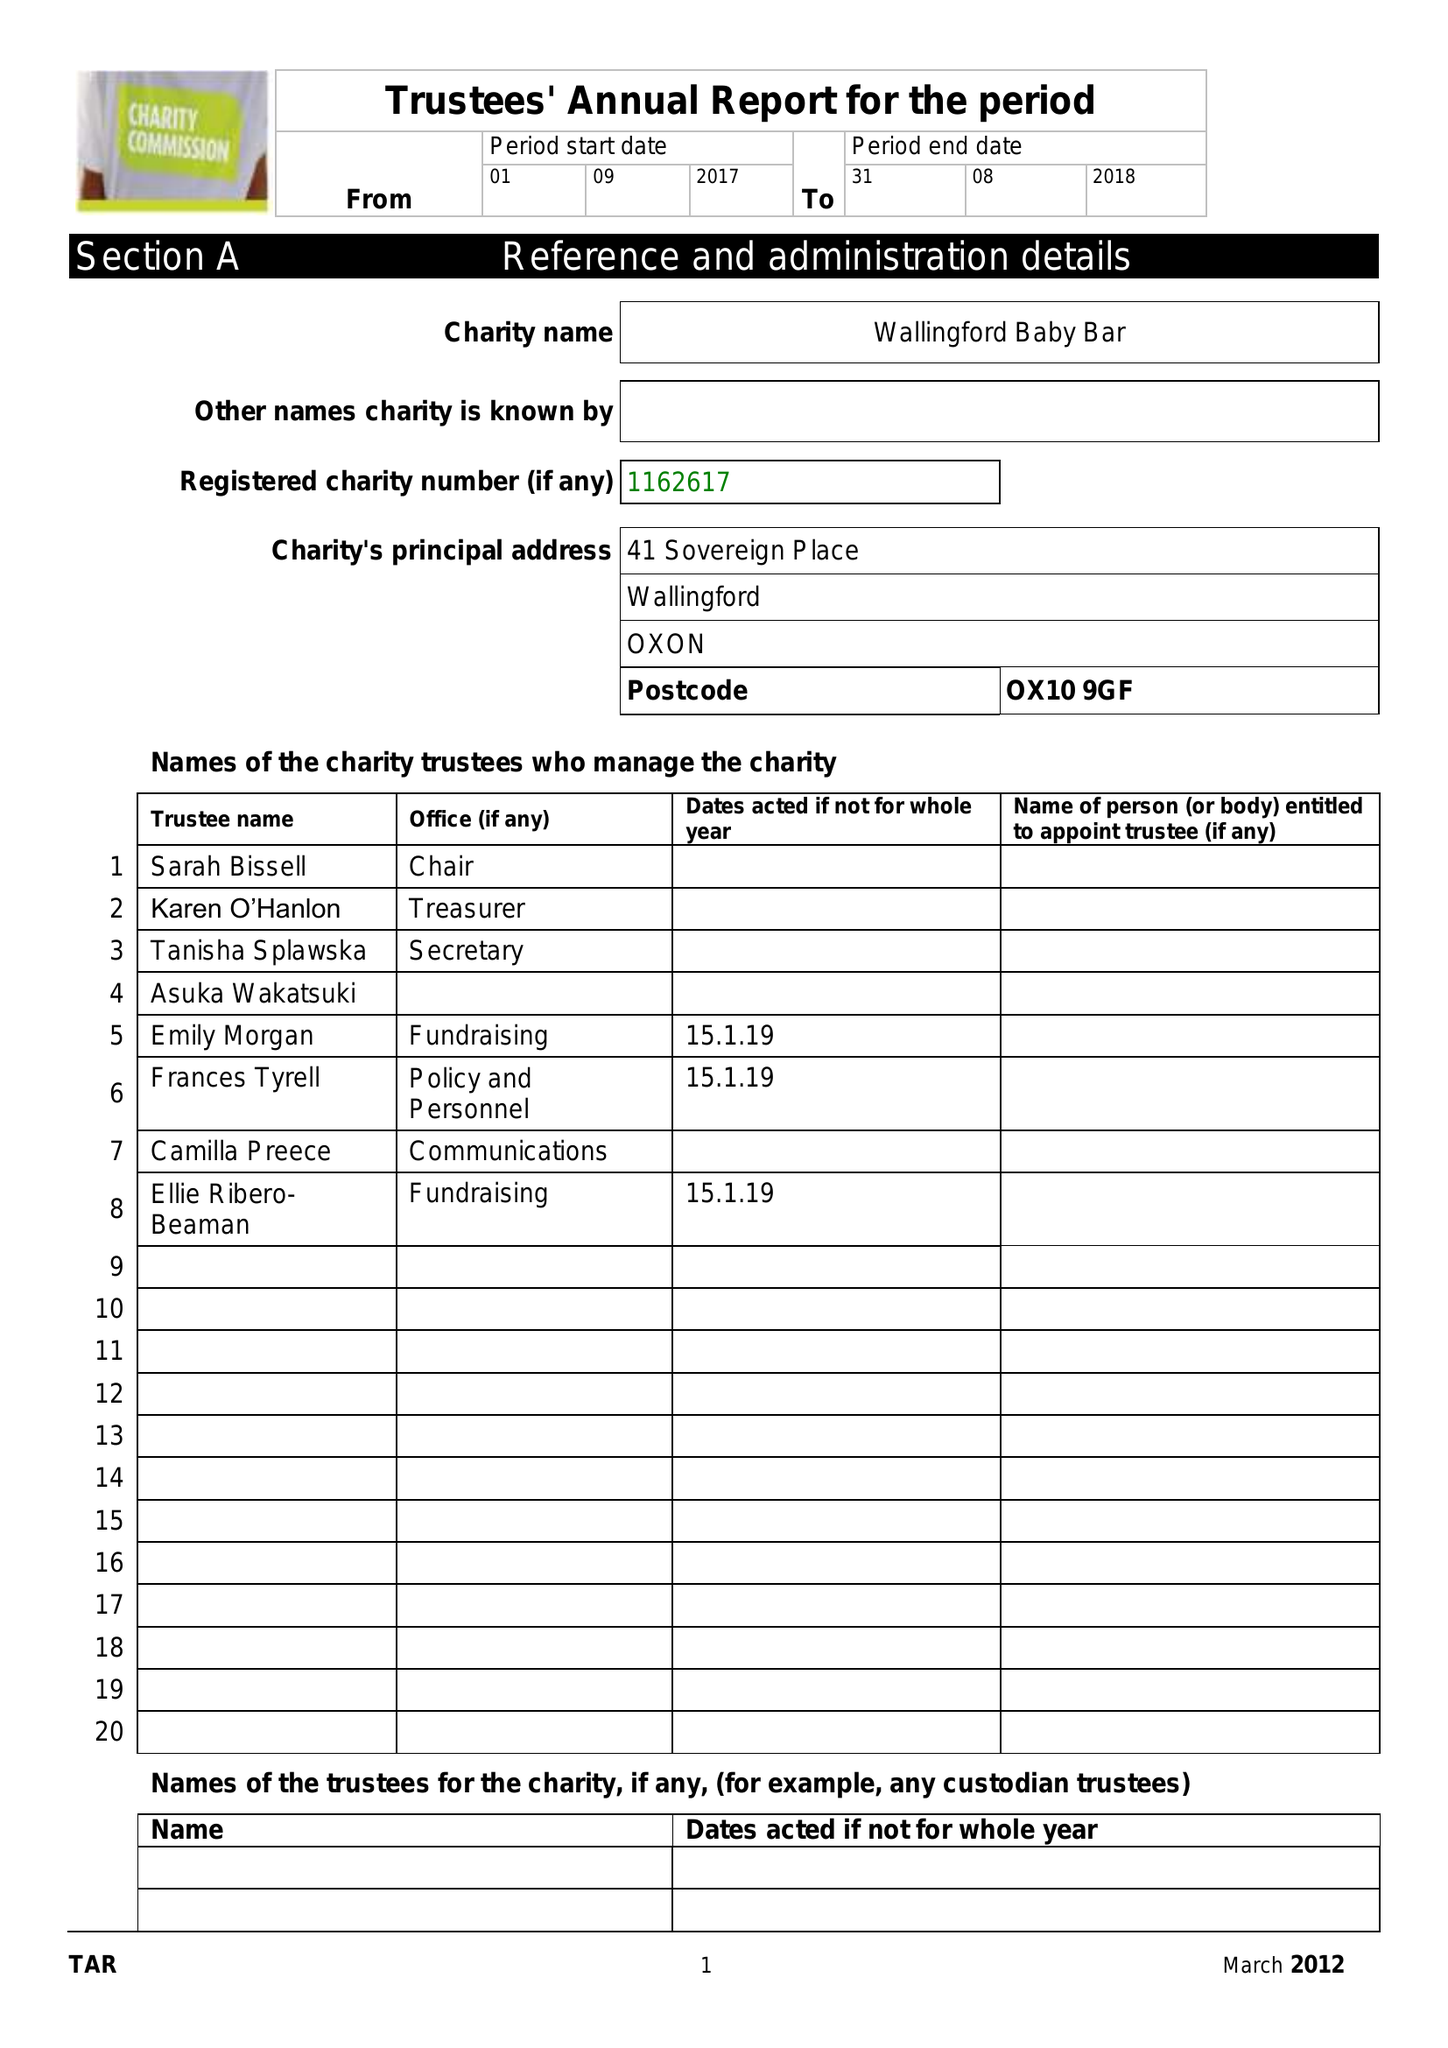What is the value for the charity_name?
Answer the question using a single word or phrase. Wallingford Baby Bar 